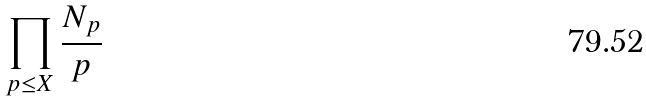Convert formula to latex. <formula><loc_0><loc_0><loc_500><loc_500>\prod _ { p \leq X } \frac { N _ { p } } { p }</formula> 